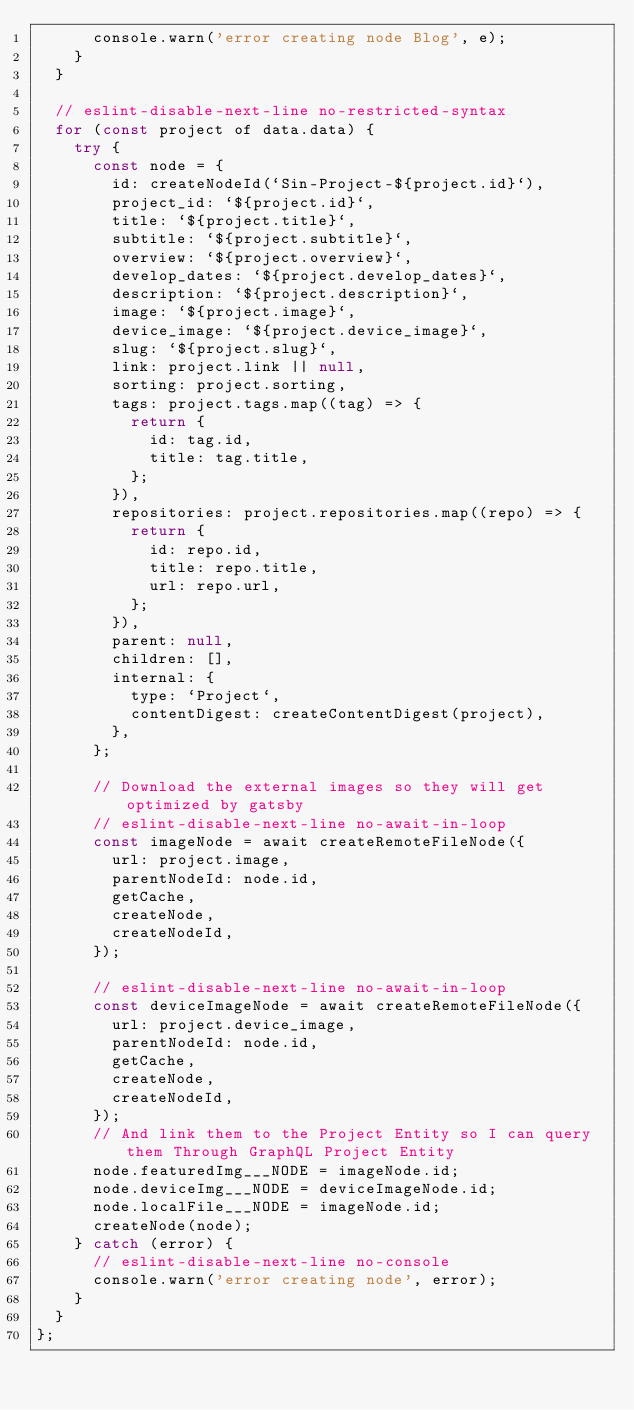Convert code to text. <code><loc_0><loc_0><loc_500><loc_500><_JavaScript_>      console.warn('error creating node Blog', e);
    }
  }

  // eslint-disable-next-line no-restricted-syntax
  for (const project of data.data) {
    try {
      const node = {
        id: createNodeId(`Sin-Project-${project.id}`),
        project_id: `${project.id}`,
        title: `${project.title}`,
        subtitle: `${project.subtitle}`,
        overview: `${project.overview}`,
        develop_dates: `${project.develop_dates}`,
        description: `${project.description}`,
        image: `${project.image}`,
        device_image: `${project.device_image}`,
        slug: `${project.slug}`,
        link: project.link || null,
        sorting: project.sorting,
        tags: project.tags.map((tag) => {
          return {
            id: tag.id,
            title: tag.title,
          };
        }),
        repositories: project.repositories.map((repo) => {
          return {
            id: repo.id,
            title: repo.title,
            url: repo.url,
          };
        }),
        parent: null,
        children: [],
        internal: {
          type: `Project`,
          contentDigest: createContentDigest(project),
        },
      };

      // Download the external images so they will get optimized by gatsby
      // eslint-disable-next-line no-await-in-loop
      const imageNode = await createRemoteFileNode({
        url: project.image,
        parentNodeId: node.id,
        getCache,
        createNode,
        createNodeId,
      });

      // eslint-disable-next-line no-await-in-loop
      const deviceImageNode = await createRemoteFileNode({
        url: project.device_image,
        parentNodeId: node.id,
        getCache,
        createNode,
        createNodeId,
      });
      // And link them to the Project Entity so I can query them Through GraphQL Project Entity
      node.featuredImg___NODE = imageNode.id;
      node.deviceImg___NODE = deviceImageNode.id;
      node.localFile___NODE = imageNode.id;
      createNode(node);
    } catch (error) {
      // eslint-disable-next-line no-console
      console.warn('error creating node', error);
    }
  }
};
</code> 